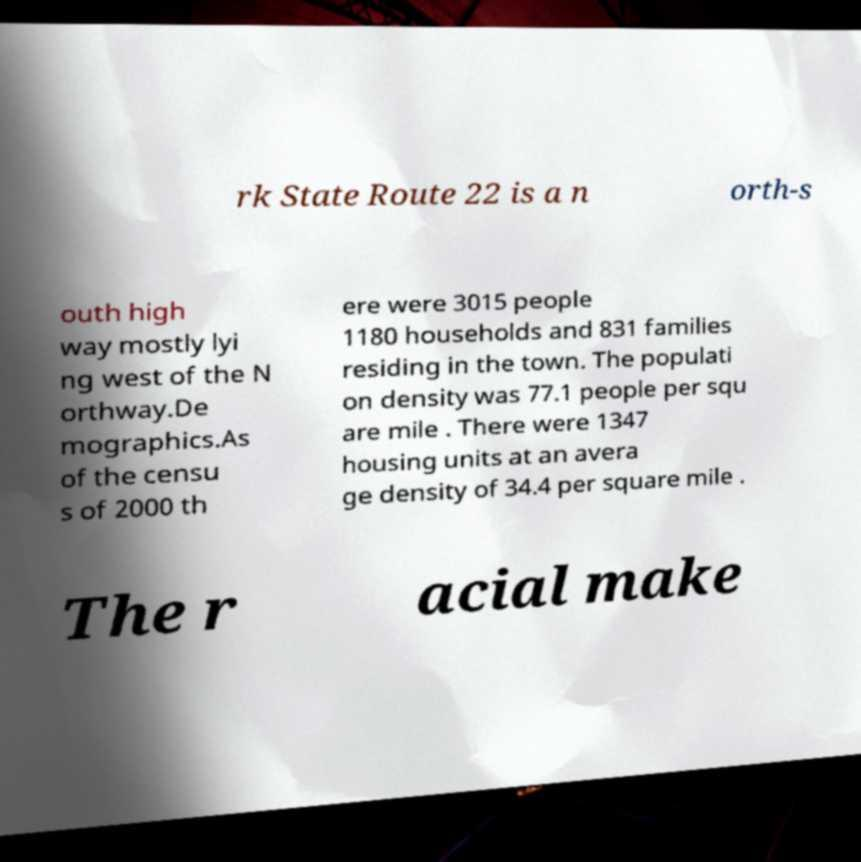For documentation purposes, I need the text within this image transcribed. Could you provide that? rk State Route 22 is a n orth-s outh high way mostly lyi ng west of the N orthway.De mographics.As of the censu s of 2000 th ere were 3015 people 1180 households and 831 families residing in the town. The populati on density was 77.1 people per squ are mile . There were 1347 housing units at an avera ge density of 34.4 per square mile . The r acial make 